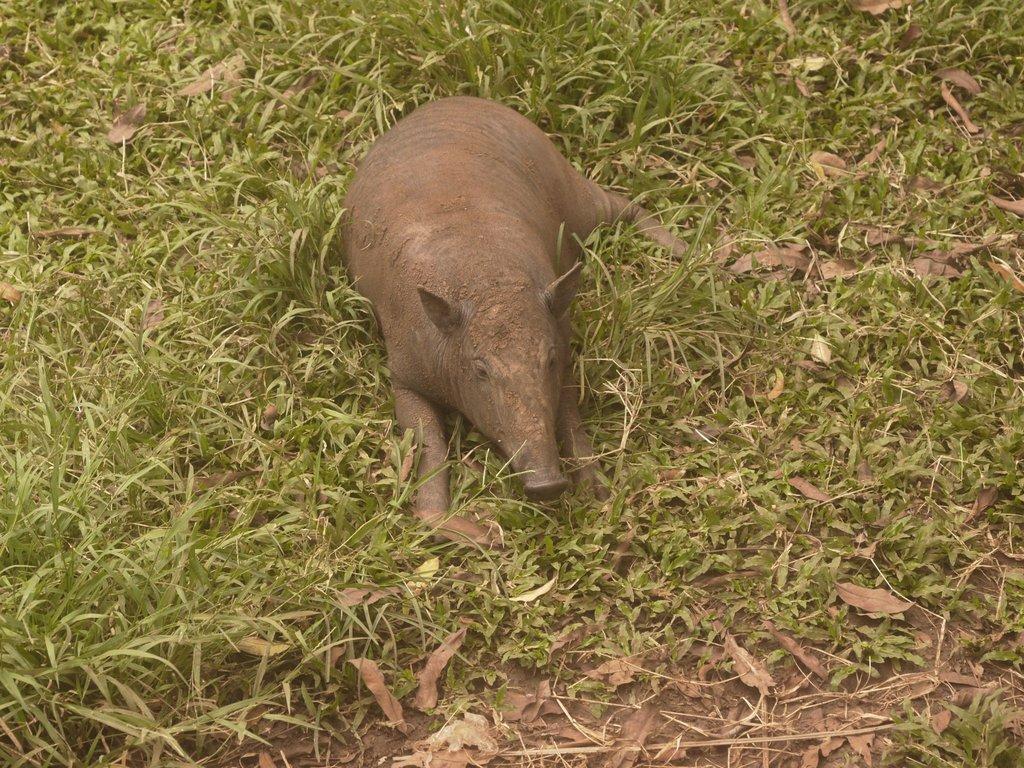Can you describe this image briefly? In this picture there is a pig, sitting on the grass. At the bottom we can see the leaves. 